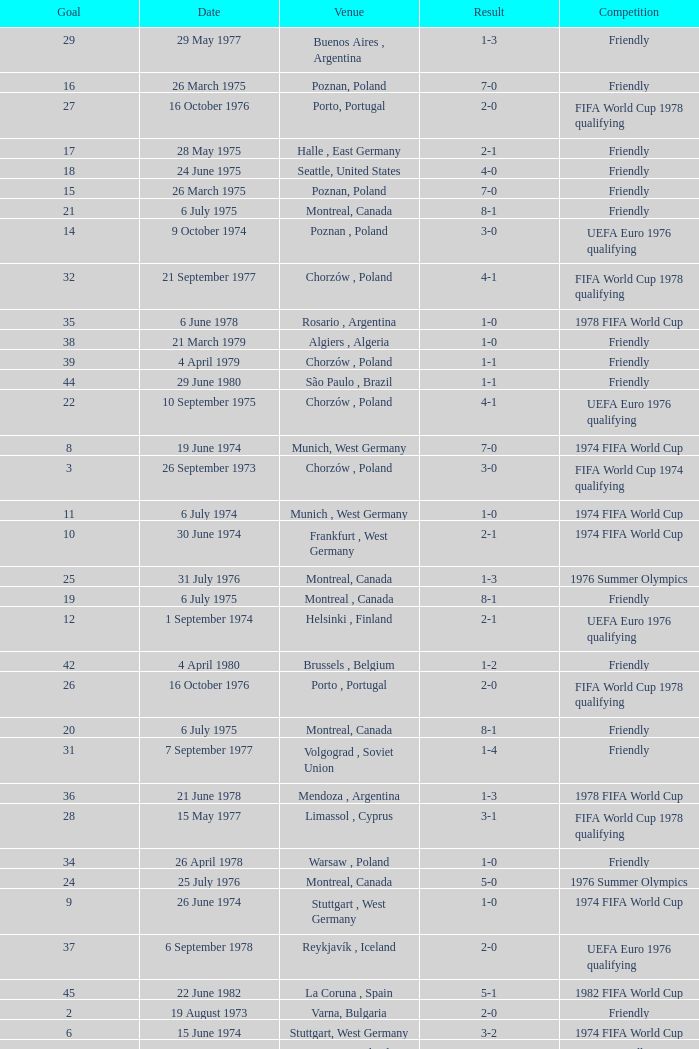Parse the full table. {'header': ['Goal', 'Date', 'Venue', 'Result', 'Competition'], 'rows': [['29', '29 May 1977', 'Buenos Aires , Argentina', '1-3', 'Friendly'], ['16', '26 March 1975', 'Poznan, Poland', '7-0', 'Friendly'], ['27', '16 October 1976', 'Porto, Portugal', '2-0', 'FIFA World Cup 1978 qualifying'], ['17', '28 May 1975', 'Halle , East Germany', '2-1', 'Friendly'], ['18', '24 June 1975', 'Seattle, United States', '4-0', 'Friendly'], ['15', '26 March 1975', 'Poznan, Poland', '7-0', 'Friendly'], ['21', '6 July 1975', 'Montreal, Canada', '8-1', 'Friendly'], ['14', '9 October 1974', 'Poznan , Poland', '3-0', 'UEFA Euro 1976 qualifying'], ['32', '21 September 1977', 'Chorzów , Poland', '4-1', 'FIFA World Cup 1978 qualifying'], ['35', '6 June 1978', 'Rosario , Argentina', '1-0', '1978 FIFA World Cup'], ['38', '21 March 1979', 'Algiers , Algeria', '1-0', 'Friendly'], ['39', '4 April 1979', 'Chorzów , Poland', '1-1', 'Friendly'], ['44', '29 June 1980', 'São Paulo , Brazil', '1-1', 'Friendly'], ['22', '10 September 1975', 'Chorzów , Poland', '4-1', 'UEFA Euro 1976 qualifying'], ['8', '19 June 1974', 'Munich, West Germany', '7-0', '1974 FIFA World Cup'], ['3', '26 September 1973', 'Chorzów , Poland', '3-0', 'FIFA World Cup 1974 qualifying'], ['11', '6 July 1974', 'Munich , West Germany', '1-0', '1974 FIFA World Cup'], ['10', '30 June 1974', 'Frankfurt , West Germany', '2-1', '1974 FIFA World Cup'], ['25', '31 July 1976', 'Montreal, Canada', '1-3', '1976 Summer Olympics'], ['19', '6 July 1975', 'Montreal , Canada', '8-1', 'Friendly'], ['12', '1 September 1974', 'Helsinki , Finland', '2-1', 'UEFA Euro 1976 qualifying'], ['42', '4 April 1980', 'Brussels , Belgium', '1-2', 'Friendly'], ['26', '16 October 1976', 'Porto , Portugal', '2-0', 'FIFA World Cup 1978 qualifying'], ['20', '6 July 1975', 'Montreal, Canada', '8-1', 'Friendly'], ['31', '7 September 1977', 'Volgograd , Soviet Union', '1-4', 'Friendly'], ['36', '21 June 1978', 'Mendoza , Argentina', '1-3', '1978 FIFA World Cup'], ['28', '15 May 1977', 'Limassol , Cyprus', '3-1', 'FIFA World Cup 1978 qualifying'], ['34', '26 April 1978', 'Warsaw , Poland', '1-0', 'Friendly'], ['24', '25 July 1976', 'Montreal, Canada', '5-0', '1976 Summer Olympics'], ['9', '26 June 1974', 'Stuttgart , West Germany', '1-0', '1974 FIFA World Cup'], ['37', '6 September 1978', 'Reykjavík , Iceland', '2-0', 'UEFA Euro 1976 qualifying'], ['45', '22 June 1982', 'La Coruna , Spain', '5-1', '1982 FIFA World Cup'], ['2', '19 August 1973', 'Varna, Bulgaria', '2-0', 'Friendly'], ['6', '15 June 1974', 'Stuttgart, West Germany', '3-2', '1974 FIFA World Cup'], ['40', '29 August 1979', 'Warsaw , Poland', '3-0', 'Friendly'], ['23', '25 July 1976', 'Montreal , Canada', '5-0', '1976 Summer Olympics'], ['43', '22 June 1980', 'Warsaw , Poland', '3-0', 'Friendly'], ['1', '19 August 1973', 'Varna , Bulgaria', '2-0', 'Friendly'], ['30', '12 June 1977', 'La Paz , Bolivia', '2-1', 'Friendly'], ['4', '15 May 1974', 'Warszawa , Poland', '2-0', 'Friendly'], ['13', '4 September 1974', 'Warsaw , Poland', '1–3', 'Friendly'], ['5', '15 June 1974', 'Stuttgart , West Germany', '3-2', '1974 FIFA World Cup'], ['33', '5 April 1978', 'Poznan , Poland', '5-2', 'Friendly'], ['7', '19 June 1974', 'Munich , West Germany', '7-0', '1974 FIFA World Cup'], ['41', '26 March 1980', 'Budapest , Hungary', '1-2', 'Friendly']]} What was the result of the game in Stuttgart, West Germany and a goal number of less than 9? 3-2, 3-2. 